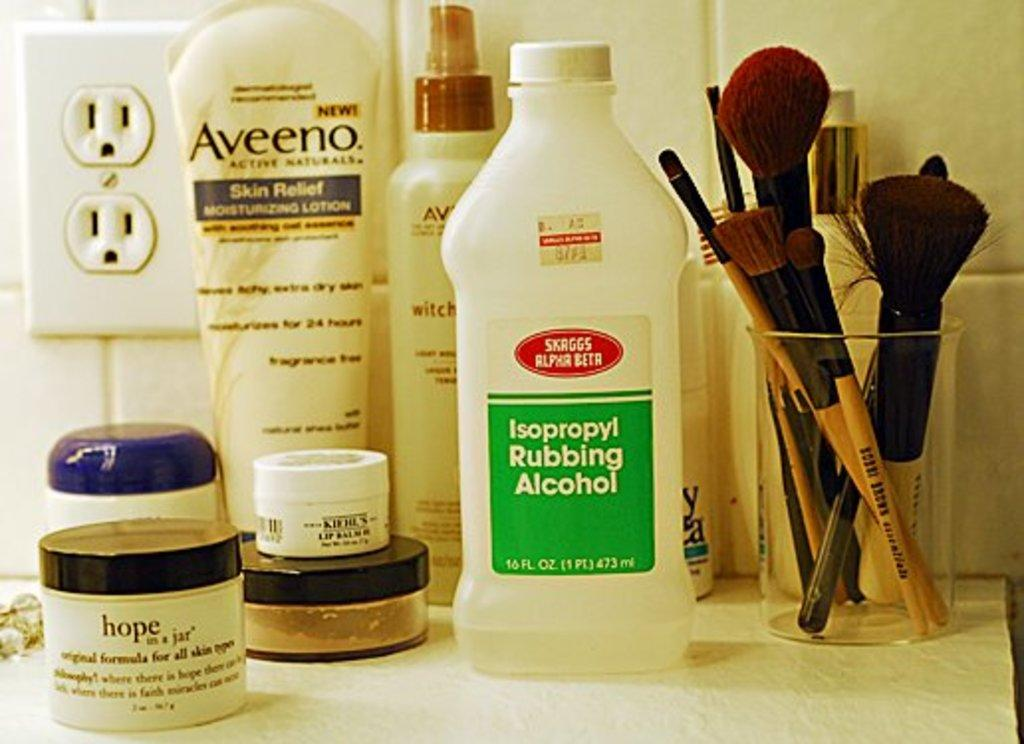Provide a one-sentence caption for the provided image. Rubbing alcohol, Aveeno lotion make up brushes and other items sitting on a counter. 